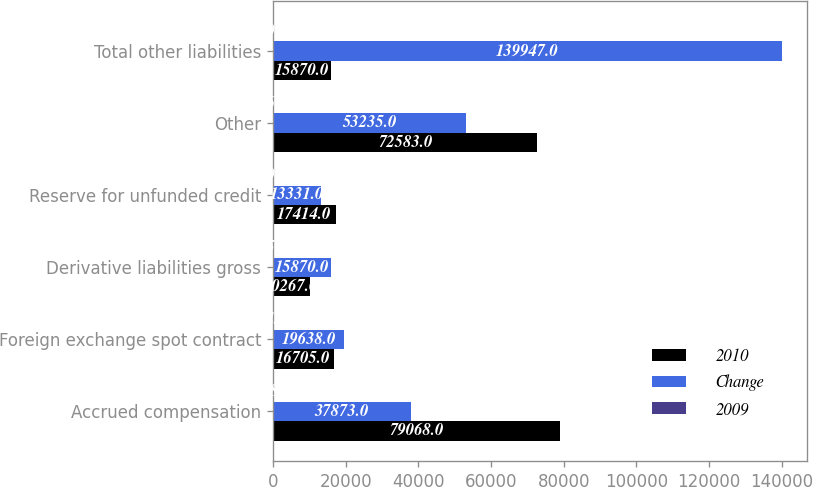Convert chart. <chart><loc_0><loc_0><loc_500><loc_500><stacked_bar_chart><ecel><fcel>Accrued compensation<fcel>Foreign exchange spot contract<fcel>Derivative liabilities gross<fcel>Reserve for unfunded credit<fcel>Other<fcel>Total other liabilities<nl><fcel>2010<fcel>79068<fcel>16705<fcel>10267<fcel>17414<fcel>72583<fcel>15870<nl><fcel>Change<fcel>37873<fcel>19638<fcel>15870<fcel>13331<fcel>53235<fcel>139947<nl><fcel>2009<fcel>108.8<fcel>14.9<fcel>35.3<fcel>30.6<fcel>36.3<fcel>40.1<nl></chart> 